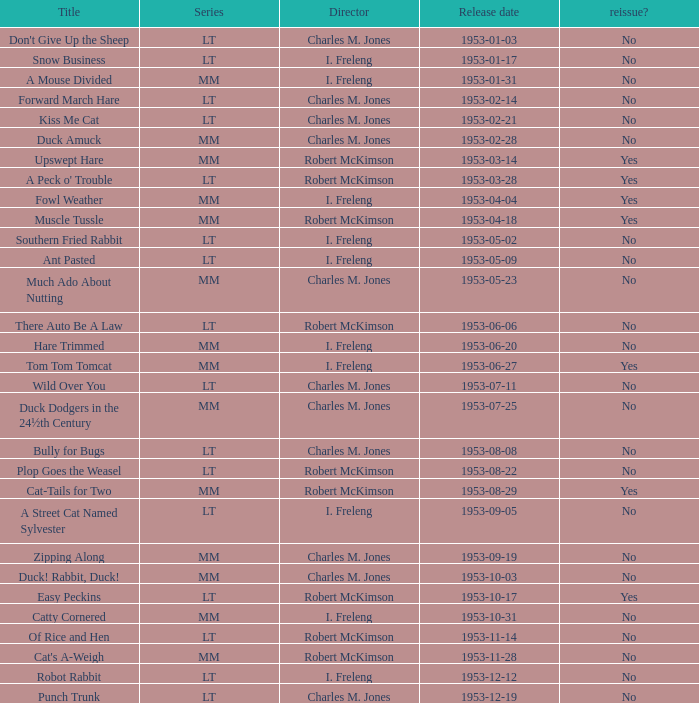Can you provide the lineup of the kiss me cat series? LT. 